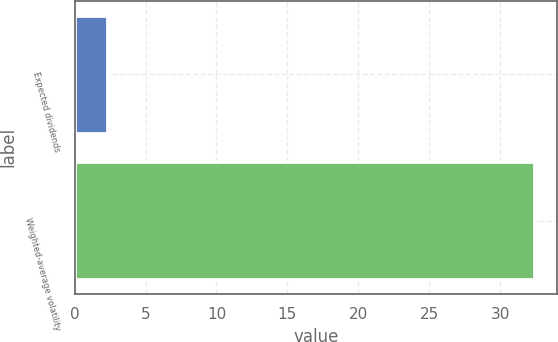<chart> <loc_0><loc_0><loc_500><loc_500><bar_chart><fcel>Expected dividends<fcel>Weighted-average volatility<nl><fcel>2.3<fcel>32.4<nl></chart> 